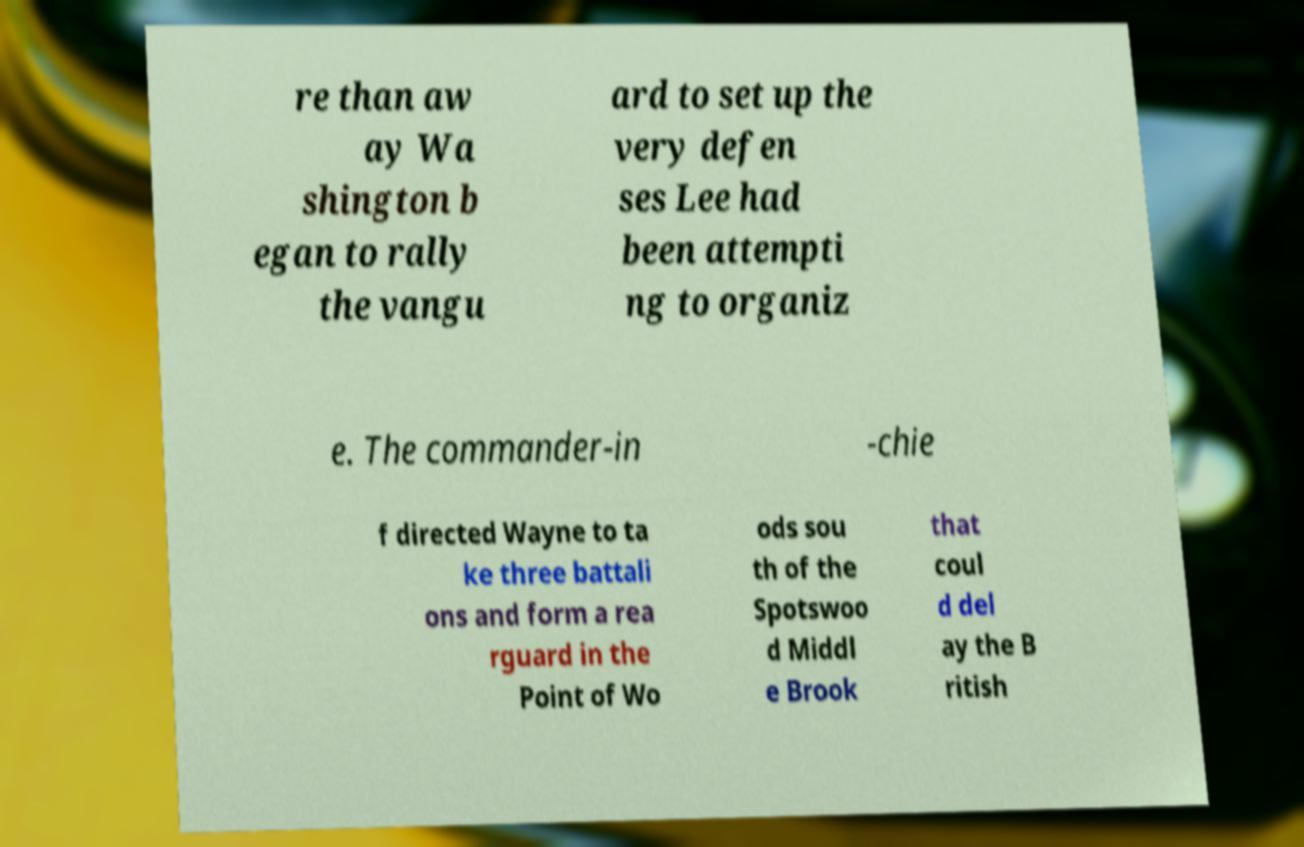There's text embedded in this image that I need extracted. Can you transcribe it verbatim? re than aw ay Wa shington b egan to rally the vangu ard to set up the very defen ses Lee had been attempti ng to organiz e. The commander-in -chie f directed Wayne to ta ke three battali ons and form a rea rguard in the Point of Wo ods sou th of the Spotswoo d Middl e Brook that coul d del ay the B ritish 